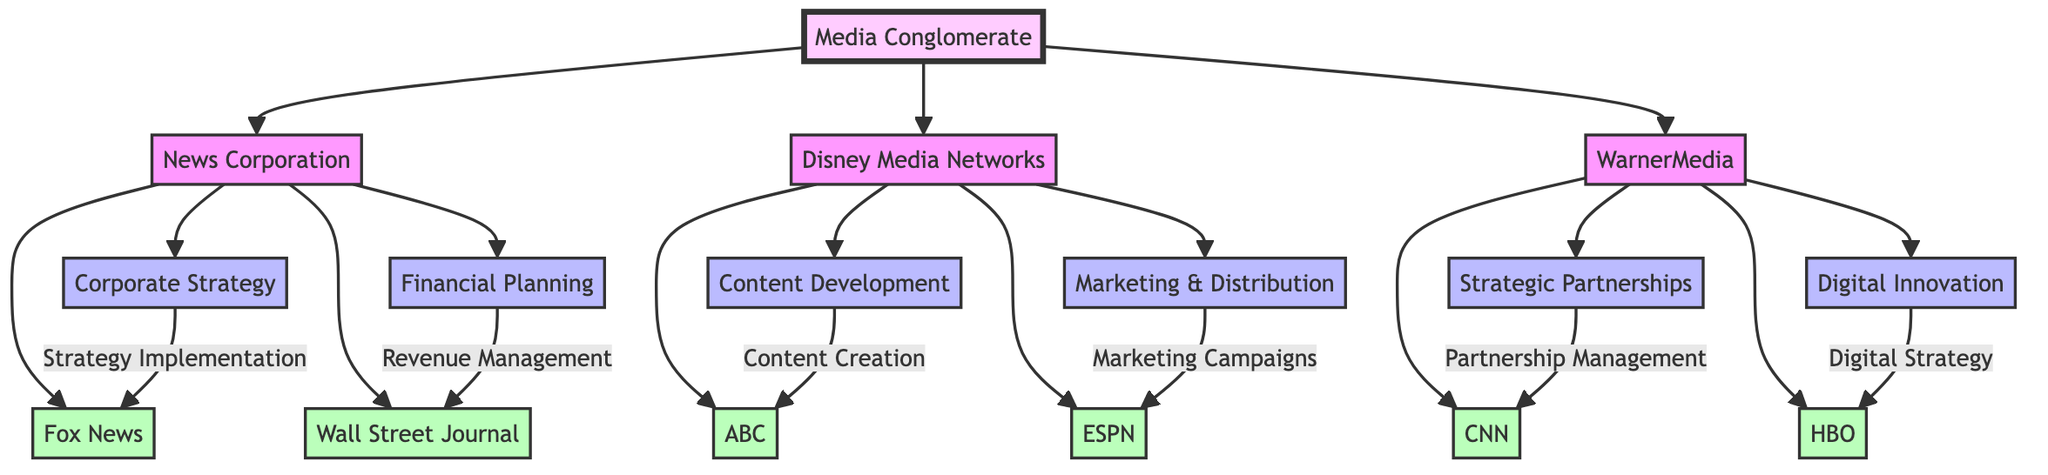What's the total number of subsidiaries shown in the diagram? The diagram shows three subsidiaries under the Media Conglomerate: News Corporation, Disney Media Networks, and WarnerMedia. Each subsidiary is represented as an individual node directly linked to the Media Conglomerate node. Thus, the total number of subsidiaries is three.
Answer: 3 Which department is responsible for 'Content Creation' in the Disney Media Networks subsidiary? The diagram indicates that 'Content Development' is the department responsible for 'Content Creation' in the Disney Media Networks subsidiary. This relationship is depicted by a directed arrow from 'Content Development' to 'ABC', which signifies a direct connection.
Answer: Content Development What is the relationship between 'Financial Planning' and 'Wall Street Journal'? 'Financial Planning' manages revenue related to the 'Wall Street Journal', which is indicated by the arrow connecting 'Financial Planning' to 'Wall Street Journal' with the label 'Revenue Management'. This indicates a flow of responsibility from financial planning to the revenue generated by the Wall Street Journal.
Answer: Revenue Management How many channels are listed under WarnerMedia? Under WarnerMedia, there are three channels listed: HBO, CNN, and the link is established from the subsidiary node to each channel. Hence, the count of channels associated with WarnerMedia is three.
Answer: 3 Which subsidiary contains the 'ESPN' channel? ESPN is listed under the Disney Media Networks subsidiary. The diagram illustrates that the Disney Media Networks node has a direct line to the ESPN channel, signifying that it is a part of that subsidiary.
Answer: Disney Media Networks What does 'Digital Innovation' relate to in WarnerMedia? 'Digital Innovation' relates to 'HBO' as shown in the diagram. The connection is represented by an arrow from 'Digital Innovation' to 'HBO', indicating that it oversees the digital strategies associated with HBO.
Answer: HBO Which department is associated with 'Marketing Campaigns' in Disney Media Networks? The department associated with 'Marketing Campaigns' is 'Marketing & Distribution'. The diagram clearly indicates that there is an arrow from 'Marketing & Distribution' pointing to 'ESPN', thereby illustrating this relationship.
Answer: Marketing & Distribution What function does 'Corporate Strategy' serve in News Corporation? 'Corporate Strategy' serves the function of 'Strategy Implementation,' particularly focused on 'Fox News'. This is evident from the direct arrow linking 'Corporate Strategy' to 'Fox News', indicating its direct role in implementing the strategy.
Answer: Strategy Implementation What type of structure does the diagram represent? The diagram represents an organizational structure showcasing the interactions and relationships between various subsidiaries, departments, and channels within a media conglomerate. This is characterized by the hierarchical layout of nodes and directed edges connecting them.
Answer: Organizational structure 